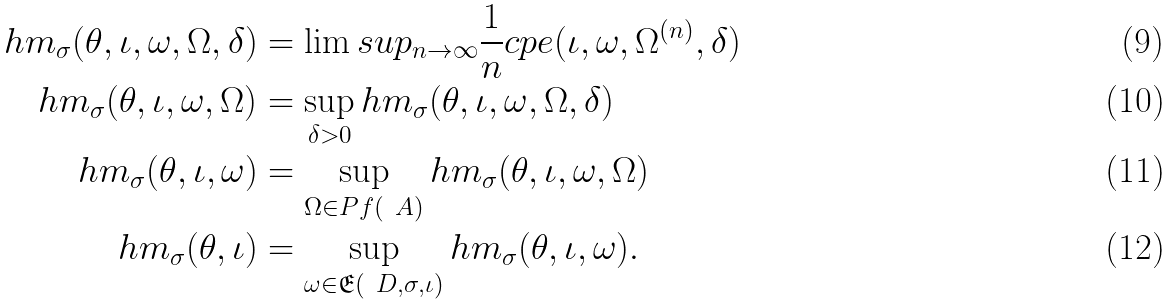Convert formula to latex. <formula><loc_0><loc_0><loc_500><loc_500>h m _ { \sigma } ( \theta , \iota , \omega , \Omega , \delta ) & = \lim s u p _ { n \to \infty } \frac { 1 } { n } c p e ( \iota , \omega , \Omega ^ { ( n ) } , \delta ) \\ h m _ { \sigma } ( \theta , \iota , \omega , \Omega ) & = \sup _ { \delta > 0 } h m _ { \sigma } ( \theta , \iota , \omega , \Omega , \delta ) \\ h m _ { \sigma } ( \theta , \iota , \omega ) & = \sup _ { \Omega \in P f ( \ A ) } h m _ { \sigma } ( \theta , \iota , \omega , \Omega ) \\ h m _ { \sigma } ( \theta , \iota ) & = \sup _ { \omega \in \mathfrak { E } ( \ D , \sigma , \iota ) } h m _ { \sigma } ( \theta , \iota , \omega ) .</formula> 